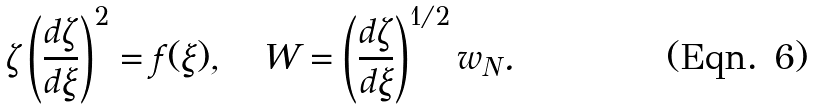<formula> <loc_0><loc_0><loc_500><loc_500>\zeta \left ( \frac { d \zeta } { d \xi } \right ) ^ { 2 } = f ( \xi ) , \quad W = \left ( \frac { d \zeta } { d \xi } \right ) ^ { 1 / 2 } w _ { N } .</formula> 